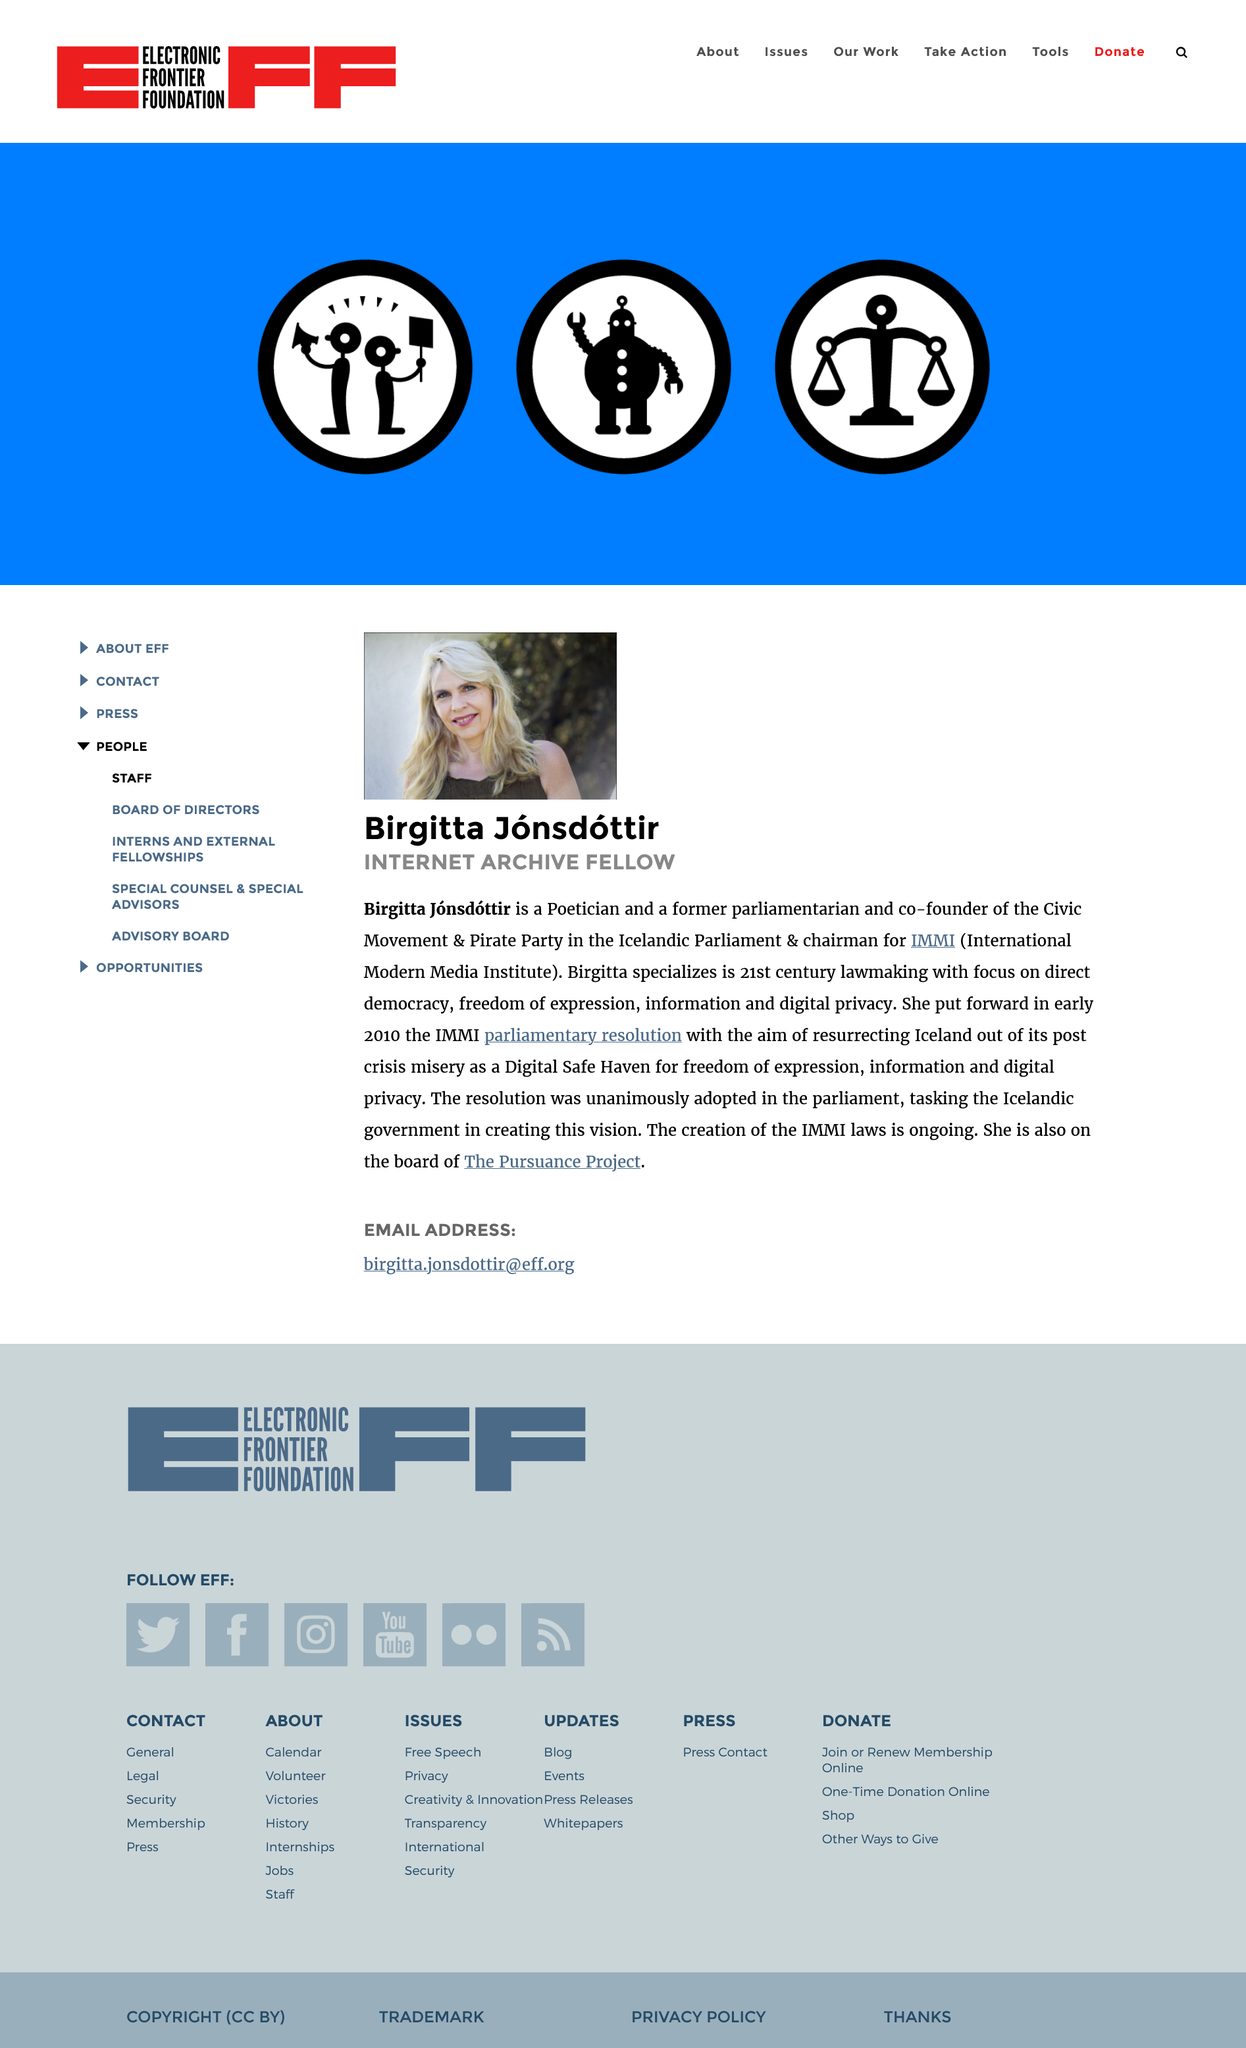Outline some significant characteristics in this image. Birgitta is an "internet archive fellow. This biography page discusses Birgitta Jonsdottir. Birgitta is from Iceland. 